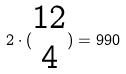Convert formula to latex. <formula><loc_0><loc_0><loc_500><loc_500>2 \cdot ( \begin{matrix} 1 2 \\ 4 \end{matrix} ) = 9 9 0</formula> 